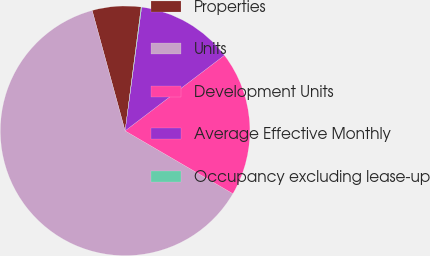Convert chart. <chart><loc_0><loc_0><loc_500><loc_500><pie_chart><fcel>Properties<fcel>Units<fcel>Development Units<fcel>Average Effective Monthly<fcel>Occupancy excluding lease-up<nl><fcel>6.3%<fcel>62.35%<fcel>18.75%<fcel>12.53%<fcel>0.07%<nl></chart> 